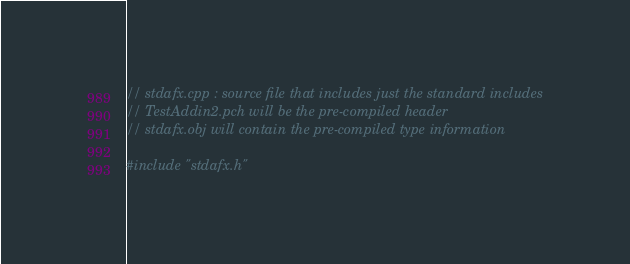Convert code to text. <code><loc_0><loc_0><loc_500><loc_500><_C++_>// stdafx.cpp : source file that includes just the standard includes
// TestAddin2.pch will be the pre-compiled header
// stdafx.obj will contain the pre-compiled type information

#include "stdafx.h"
</code> 